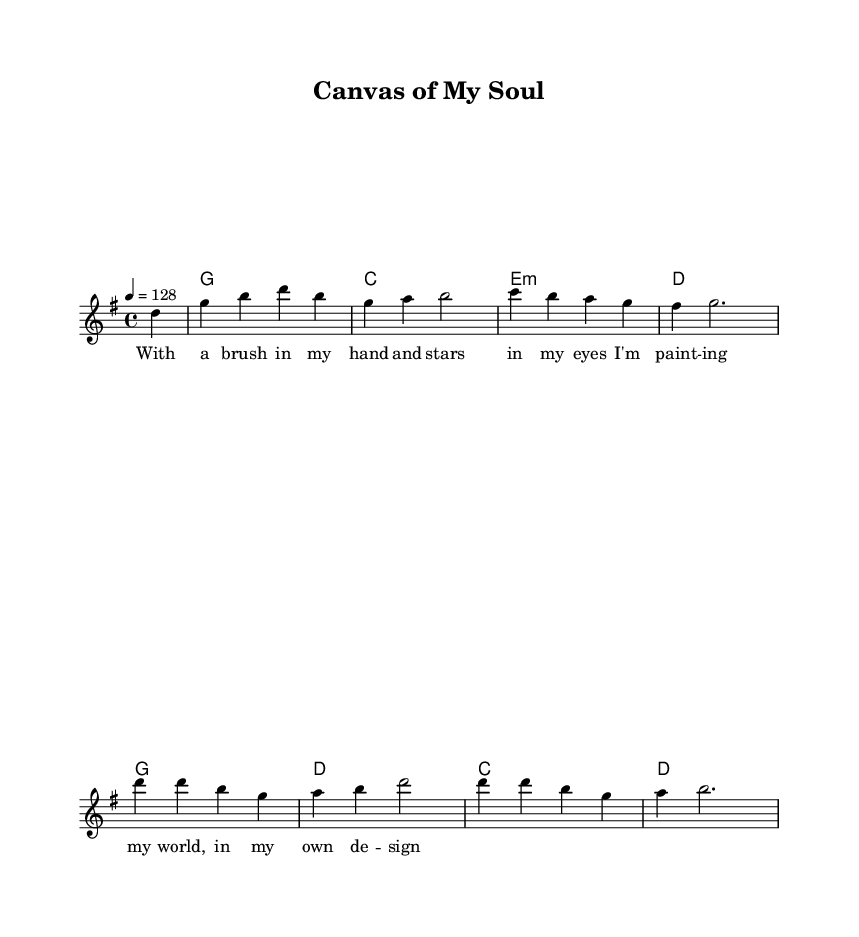What is the key signature of this music? The key signature is G major, which has one sharp (F#). This can be identified by looking at the key signature at the beginning of the staff.
Answer: G major What is the time signature of this piece? The time signature is 4/4, which is indicated at the beginning of the staff. This means there are four beats in each measure, and the quarter note gets one beat.
Answer: 4/4 What is the tempo marking for this music? The tempo marking is 128, which is specified as "4 = 128." This indicates that there are 128 beats per minute when played at a quarter note's duration.
Answer: 128 How many measures are in the melody? There are 8 measures in the melody, as can be counted by looking at the vertical lines that separate the measures in the notation.
Answer: 8 What chords are used in the first measure? The chords in the first measure are G. This can be identified by looking at the chord symbols above the staff.
Answer: G Which line in the lyrics emphasizes individuality? The line "I'm paint -- ing my world, in my own de -- sign" emphasizes individuality, showcasing the theme of personal expression through art. It highlights the singer's creative freedom and self-identity.
Answer: "I'm paint -- ing my world, in my own de -- sign." What genre does this sheet music represent? The genre represented is country rock, characterized by its upbeat tempo and themes of self-expression and individuality. This can be inferred from the overall style and content of the lyrics and melody.
Answer: Country rock 